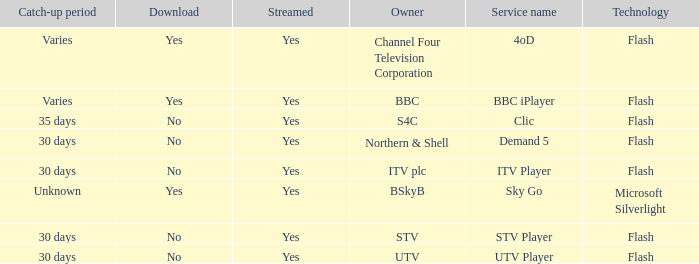What service moniker is possessed by utv? UTV Player. 